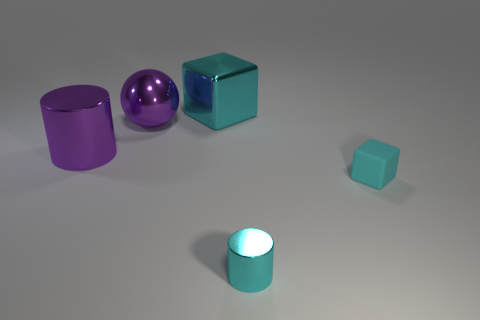Add 1 big blue things. How many objects exist? 6 Subtract all cylinders. How many objects are left? 3 Add 5 big purple metal things. How many big purple metal things exist? 7 Subtract 0 brown spheres. How many objects are left? 5 Subtract all large rubber things. Subtract all big cylinders. How many objects are left? 4 Add 3 large purple metal balls. How many large purple metal balls are left? 4 